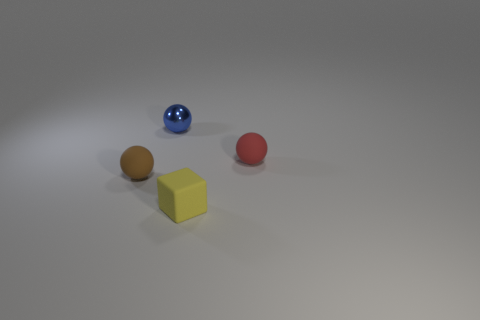Are there any other things that are the same material as the small blue thing?
Ensure brevity in your answer.  No. Is there any other thing that has the same shape as the yellow object?
Ensure brevity in your answer.  No. What size is the object that is to the left of the tiny matte block and to the right of the small brown thing?
Provide a succinct answer. Small. There is a red rubber object; what shape is it?
Ensure brevity in your answer.  Sphere. What number of things are either big red spheres or small rubber balls that are behind the small brown matte object?
Keep it short and to the point. 1. The tiny object that is both on the left side of the yellow block and on the right side of the small brown sphere is what color?
Offer a terse response. Blue. What is the material of the tiny sphere to the left of the tiny metal object?
Ensure brevity in your answer.  Rubber. How many yellow things are blocks or small metallic objects?
Your answer should be compact. 1. There is a small shiny sphere; is it the same color as the object that is right of the cube?
Give a very brief answer. No. What number of other objects are the same material as the small red object?
Your response must be concise. 2. 